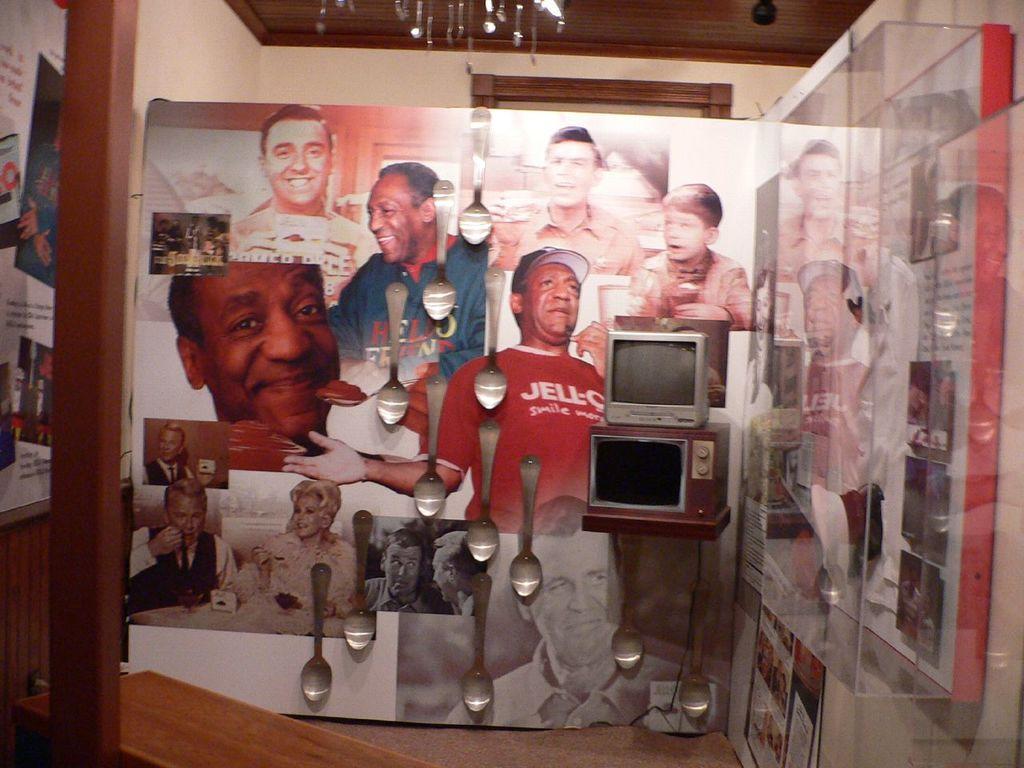Please provide a concise description of this image. This is an inside view of a room. On the right side, I can see a glass. On the left side there is a pillar. In the background there is a board on which I can see few images of persons and few spoons are attached to that board. In front of this board I can see a television. At the top I can see in the wall and a chandelier. 